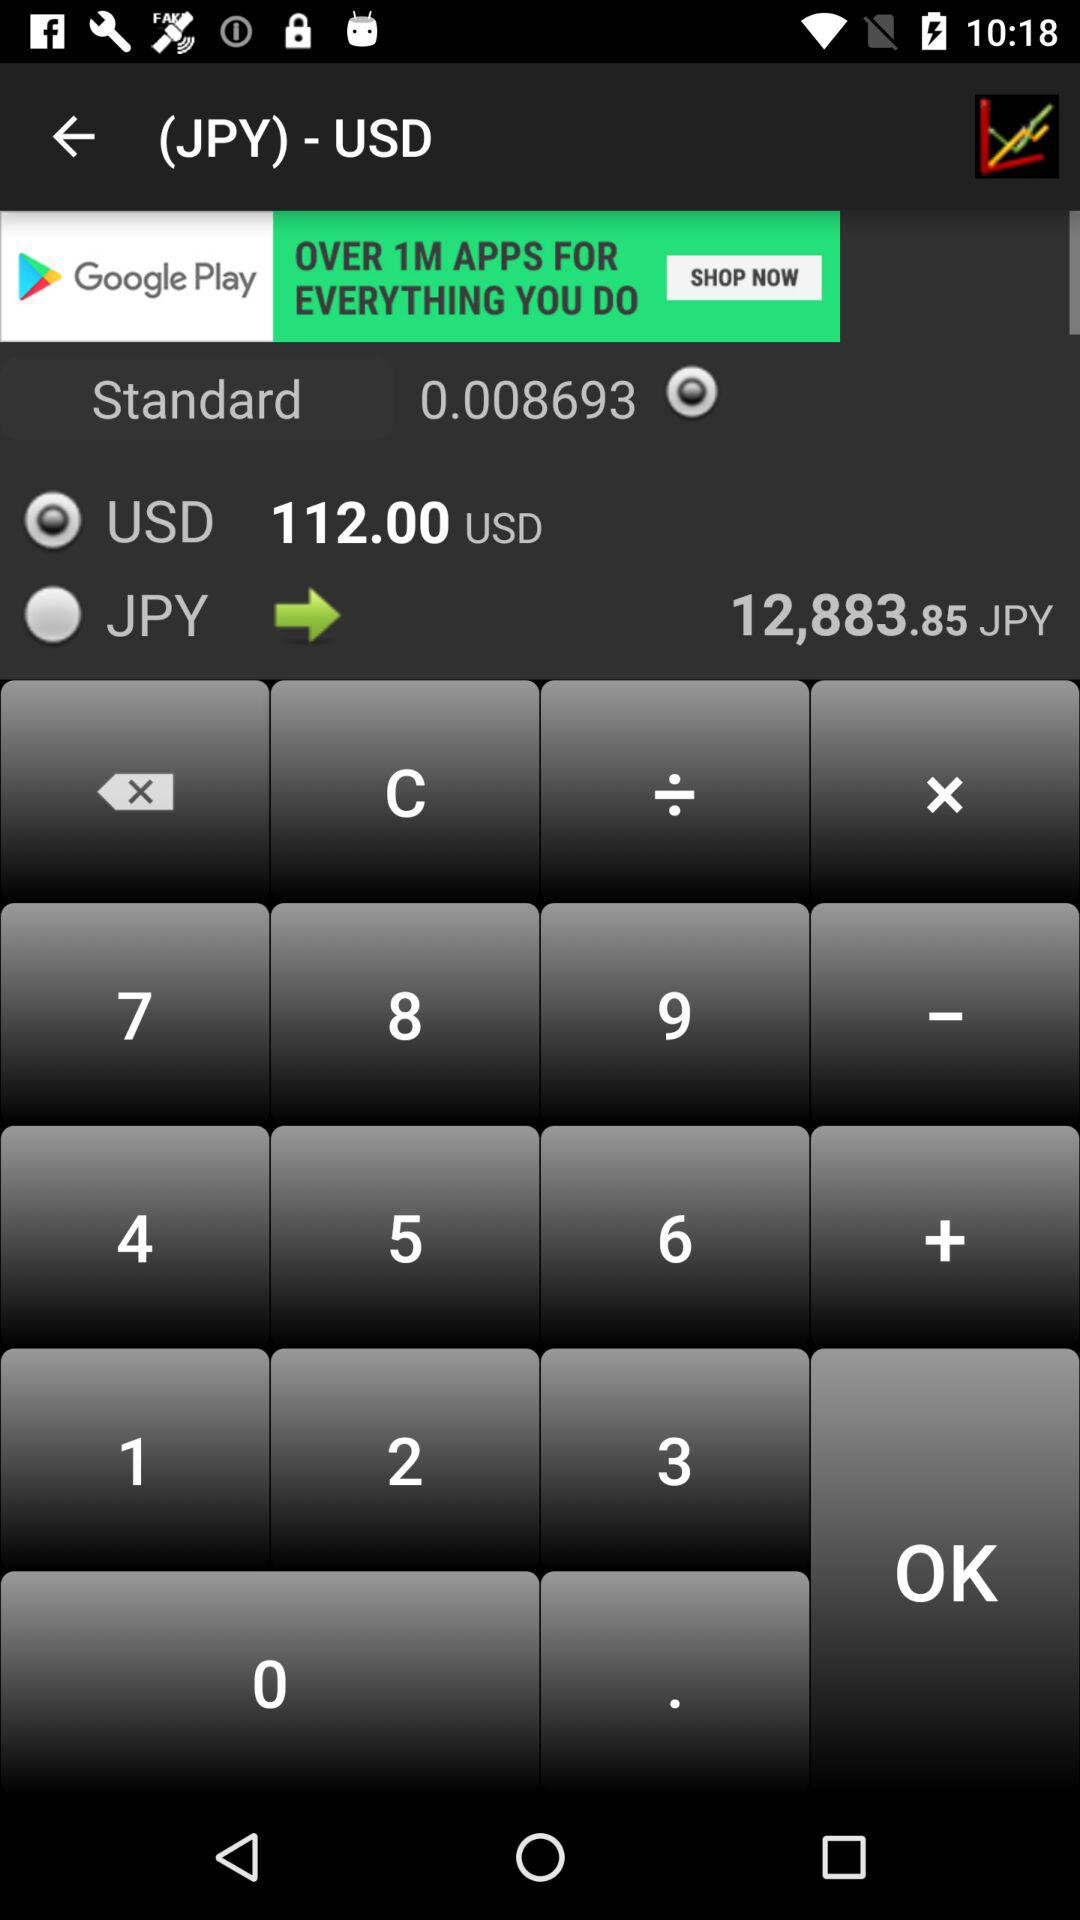What is the value of the USD? The value of the USD is 112.00. 